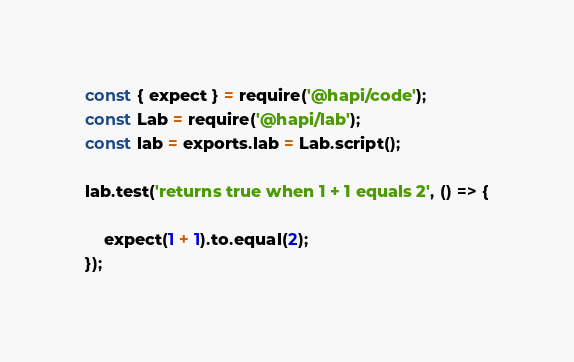Convert code to text. <code><loc_0><loc_0><loc_500><loc_500><_JavaScript_>const { expect } = require('@hapi/code');
const Lab = require('@hapi/lab');
const lab = exports.lab = Lab.script();

lab.test('returns true when 1 + 1 equals 2', () => {

    expect(1 + 1).to.equal(2);
});
</code> 